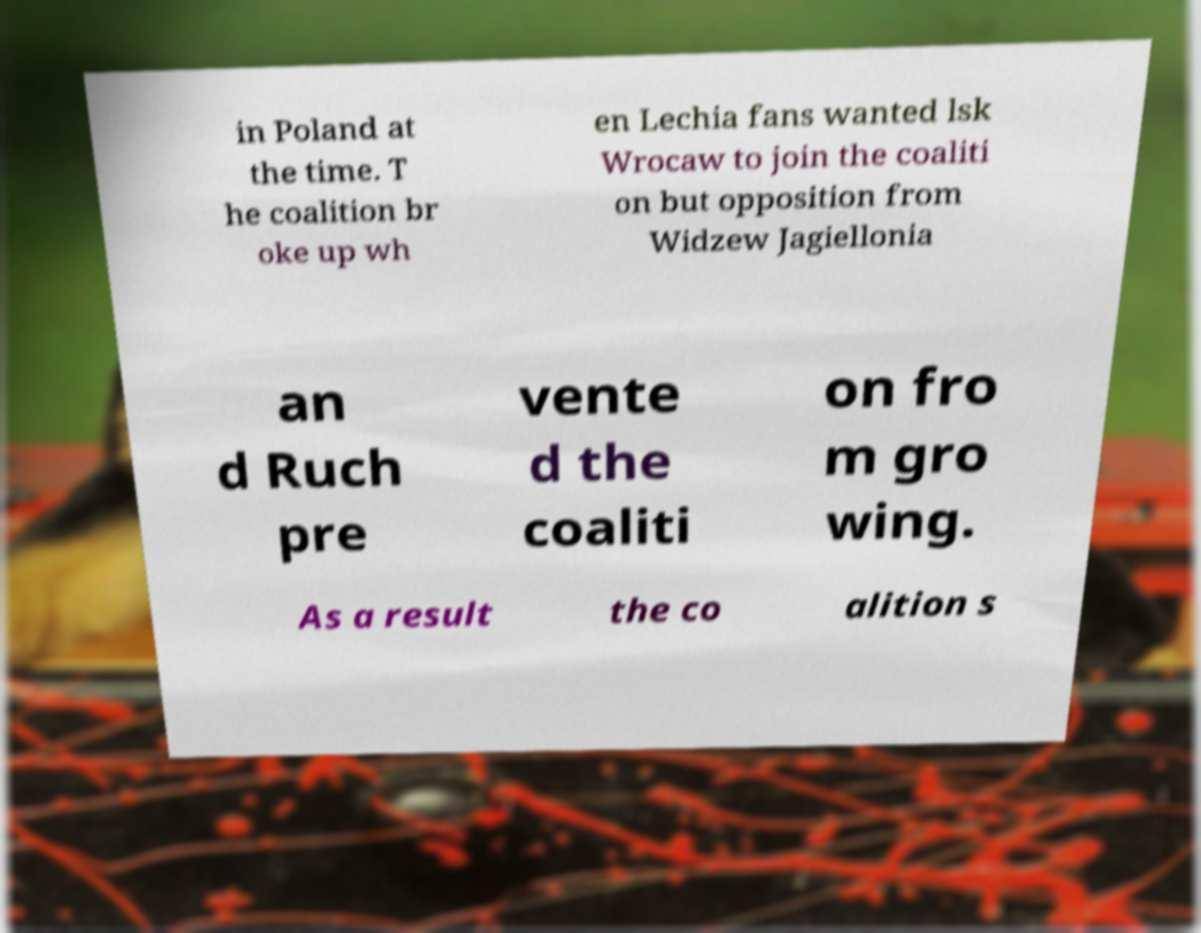Could you assist in decoding the text presented in this image and type it out clearly? in Poland at the time. T he coalition br oke up wh en Lechia fans wanted lsk Wrocaw to join the coaliti on but opposition from Widzew Jagiellonia an d Ruch pre vente d the coaliti on fro m gro wing. As a result the co alition s 